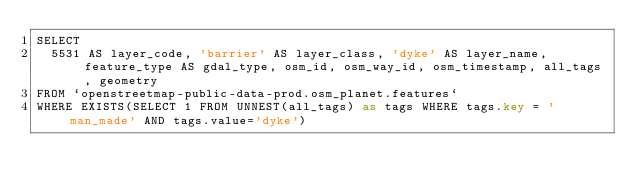<code> <loc_0><loc_0><loc_500><loc_500><_SQL_>SELECT
  5531 AS layer_code, 'barrier' AS layer_class, 'dyke' AS layer_name, feature_type AS gdal_type, osm_id, osm_way_id, osm_timestamp, all_tags, geometry
FROM `openstreetmap-public-data-prod.osm_planet.features`
WHERE EXISTS(SELECT 1 FROM UNNEST(all_tags) as tags WHERE tags.key = 'man_made' AND tags.value='dyke')
</code> 